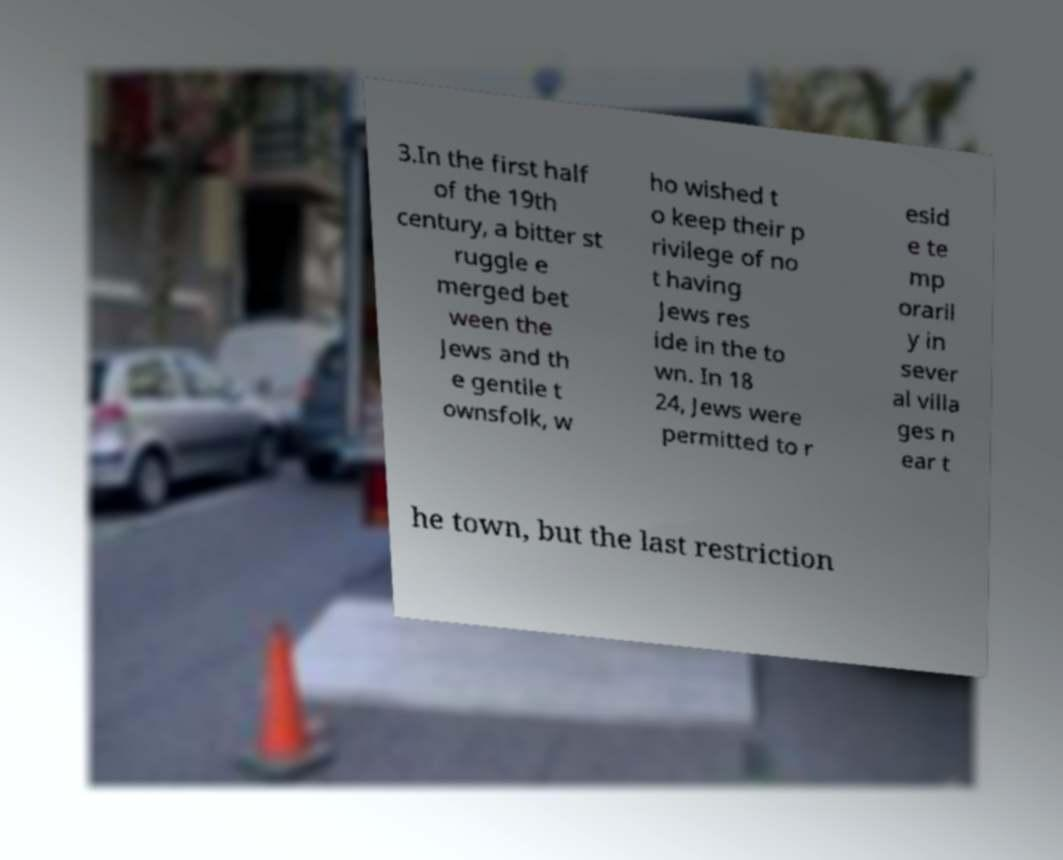Could you extract and type out the text from this image? 3.In the first half of the 19th century, a bitter st ruggle e merged bet ween the Jews and th e gentile t ownsfolk, w ho wished t o keep their p rivilege of no t having Jews res ide in the to wn. In 18 24, Jews were permitted to r esid e te mp oraril y in sever al villa ges n ear t he town, but the last restriction 